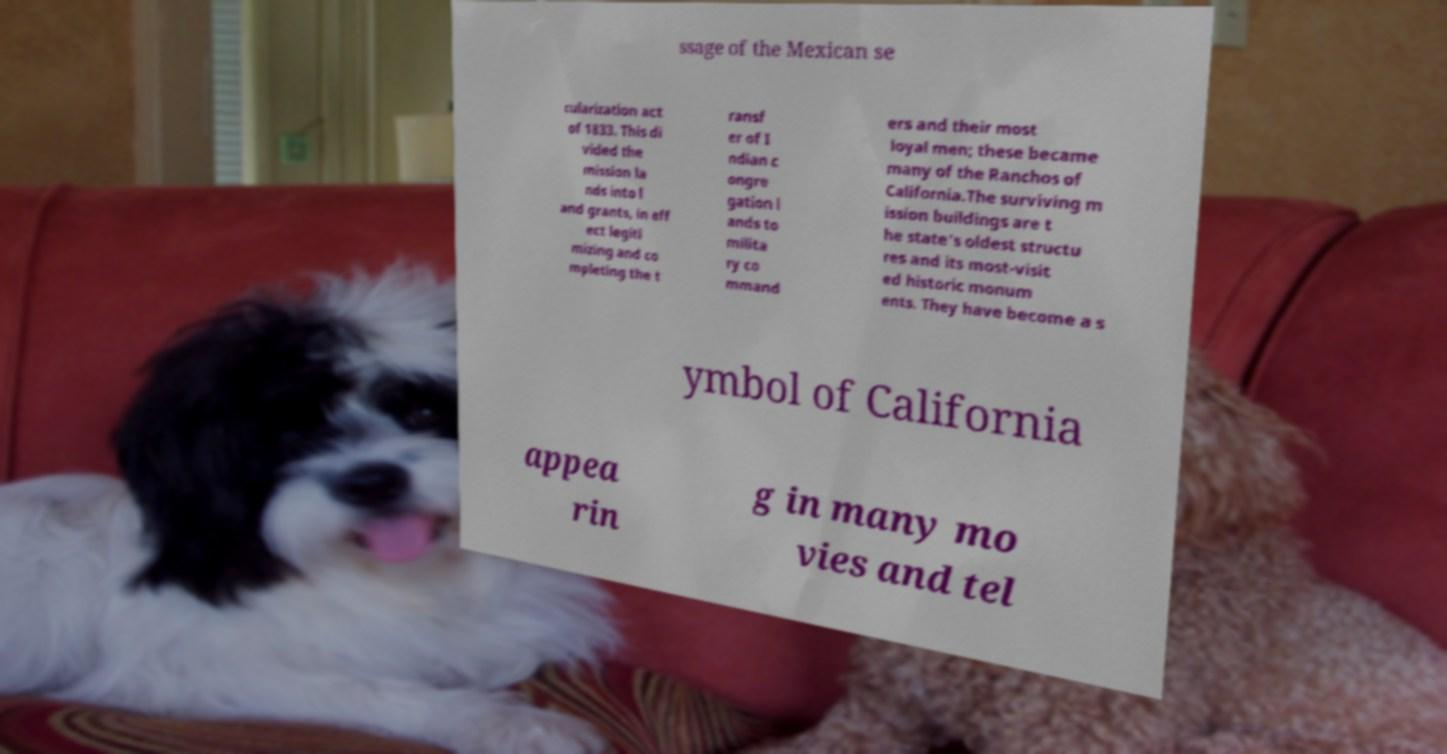Can you accurately transcribe the text from the provided image for me? ssage of the Mexican se cularization act of 1833. This di vided the mission la nds into l and grants, in eff ect legiti mizing and co mpleting the t ransf er of I ndian c ongre gation l ands to milita ry co mmand ers and their most loyal men; these became many of the Ranchos of California.The surviving m ission buildings are t he state's oldest structu res and its most-visit ed historic monum ents. They have become a s ymbol of California appea rin g in many mo vies and tel 